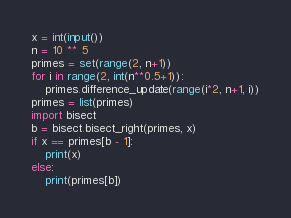Convert code to text. <code><loc_0><loc_0><loc_500><loc_500><_Python_>x = int(input())
n = 10 ** 5
primes = set(range(2, n+1))
for i in range(2, int(n**0.5+1)):
    primes.difference_update(range(i*2, n+1, i))
primes = list(primes)
import bisect
b = bisect.bisect_right(primes, x)
if x == primes[b - 1]:
    print(x)
else:
    print(primes[b])</code> 